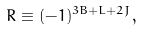<formula> <loc_0><loc_0><loc_500><loc_500>R \equiv ( - 1 ) ^ { 3 B + L + 2 J } ,</formula> 